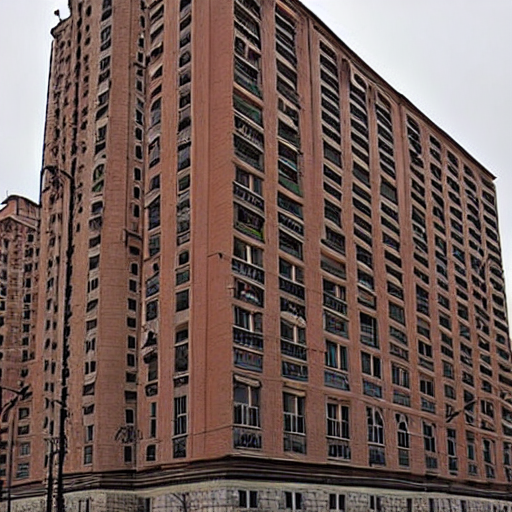Where is this house situated (in Russia)? The house is situated in Russia, in the city of Moscow. It is located in the Northern Administrative Okrug, in the district of Koptevo. The house is a 17-story residential building, built in the 1970s. 